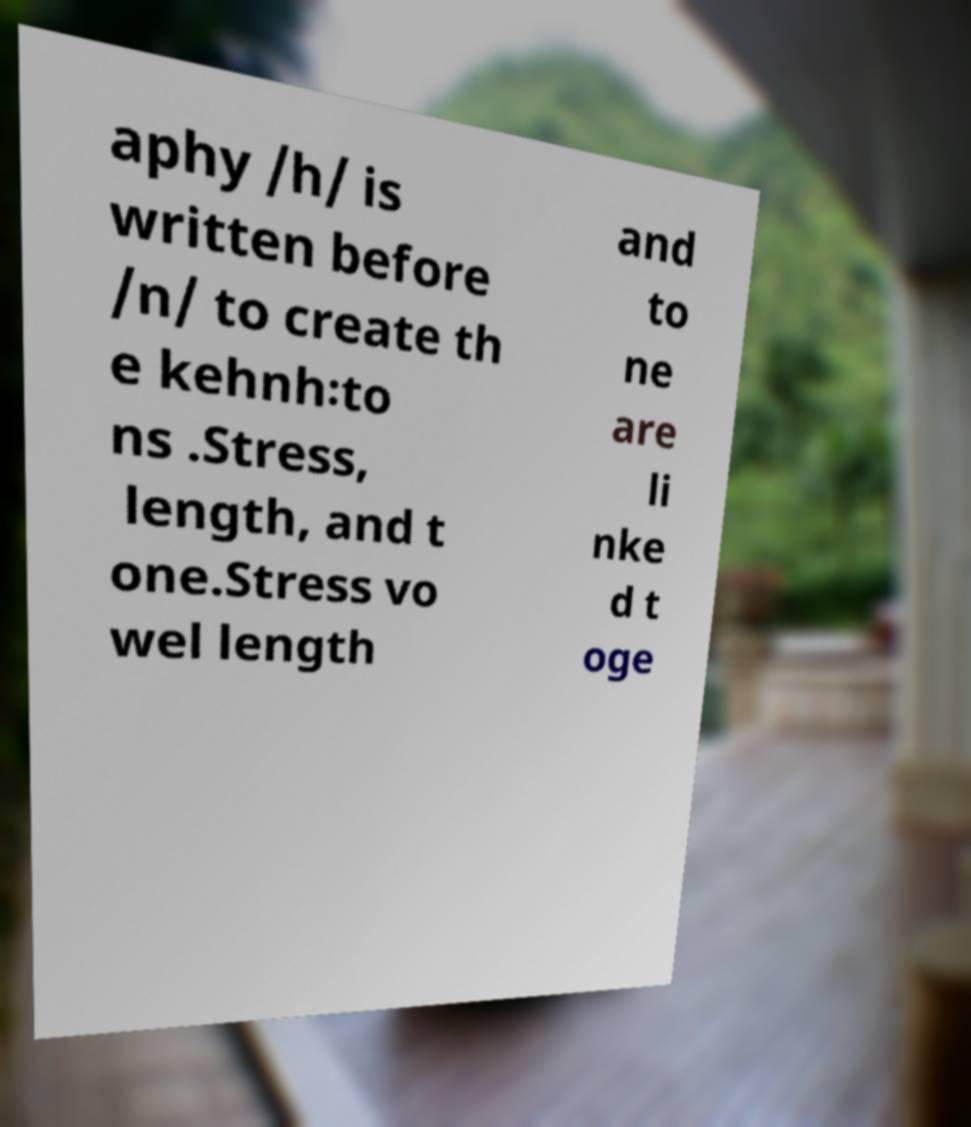There's text embedded in this image that I need extracted. Can you transcribe it verbatim? aphy /h/ is written before /n/ to create th e kehnh꞉to ns .Stress, length, and t one.Stress vo wel length and to ne are li nke d t oge 